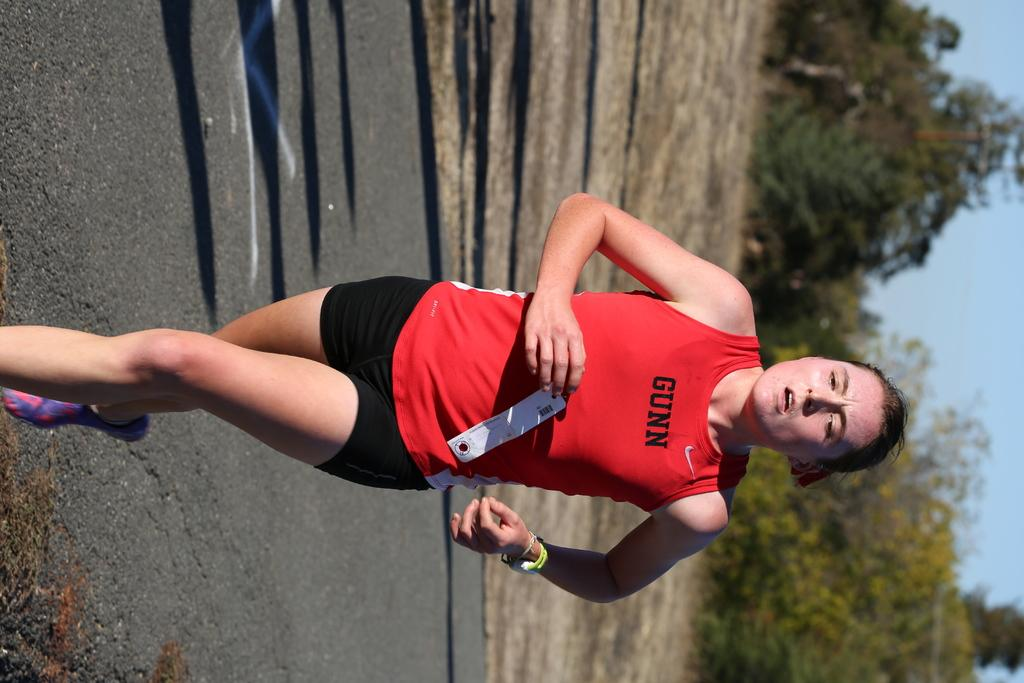<image>
Write a terse but informative summary of the picture. The runner is wearing a red tank top that says "gunn" on it. 